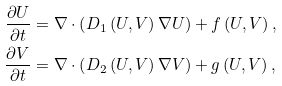<formula> <loc_0><loc_0><loc_500><loc_500>\frac { \partial U } { \partial t } & = \nabla \cdot \left ( D _ { 1 } \left ( U , V \right ) \nabla U \right ) + f \left ( U , V \right ) , \\ \frac { \partial V } { \partial t } & = \nabla \cdot \left ( D _ { 2 } \left ( U , V \right ) \nabla V \right ) + g \left ( U , V \right ) ,</formula> 